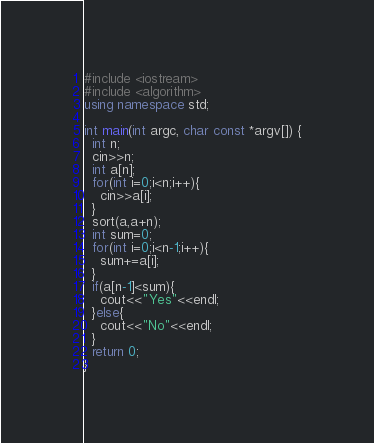<code> <loc_0><loc_0><loc_500><loc_500><_C++_>#include <iostream>
#include <algorithm>
using namespace std;

int main(int argc, char const *argv[]) {
  int n;
  cin>>n;
  int a[n];
  for(int i=0;i<n;i++){
    cin>>a[i];
  }
  sort(a,a+n);
  int sum=0;
  for(int i=0;i<n-1;i++){
    sum+=a[i];
  }
  if(a[n-1]<sum){
    cout<<"Yes"<<endl;
  }else{
    cout<<"No"<<endl;
  }
  return 0;
}
</code> 